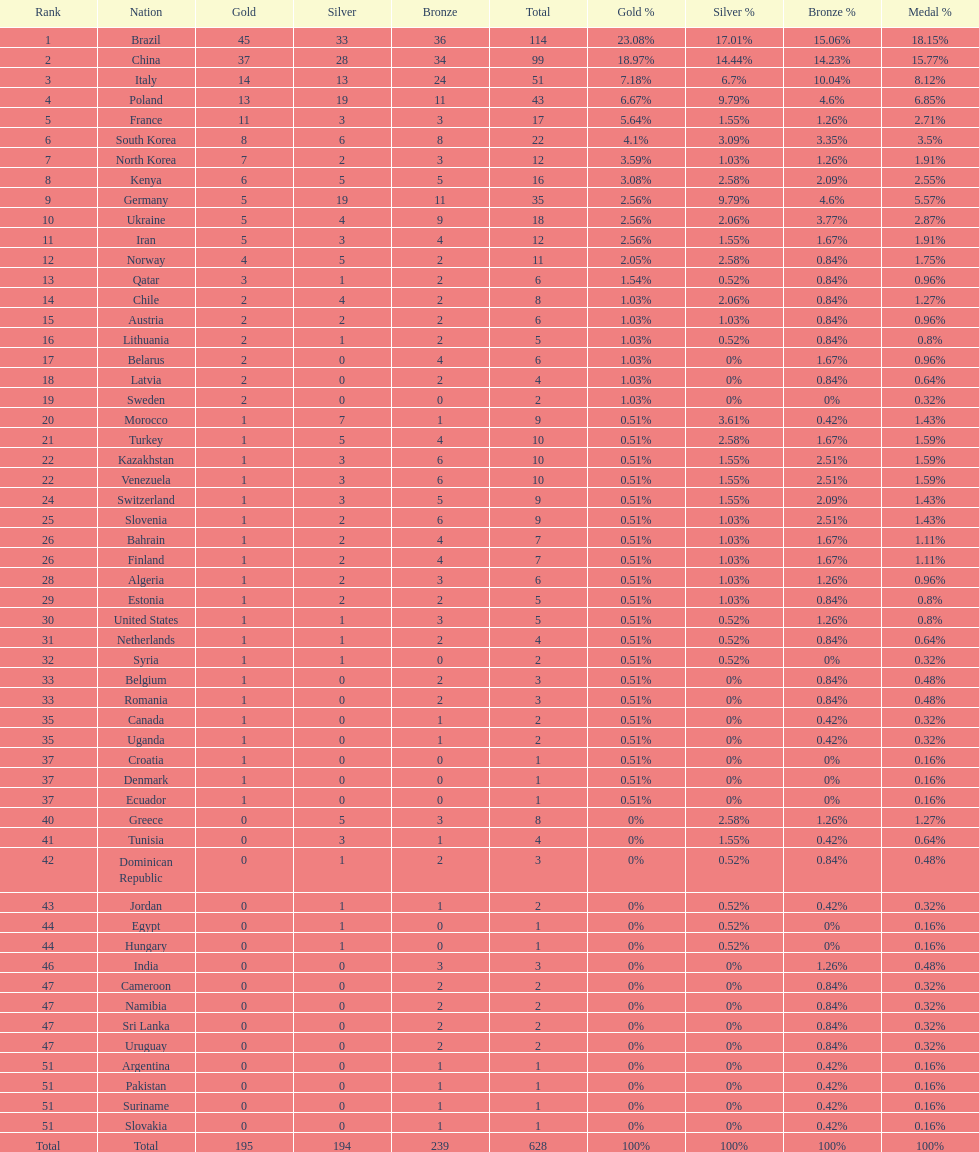South korea has how many more medals that north korea? 10. 